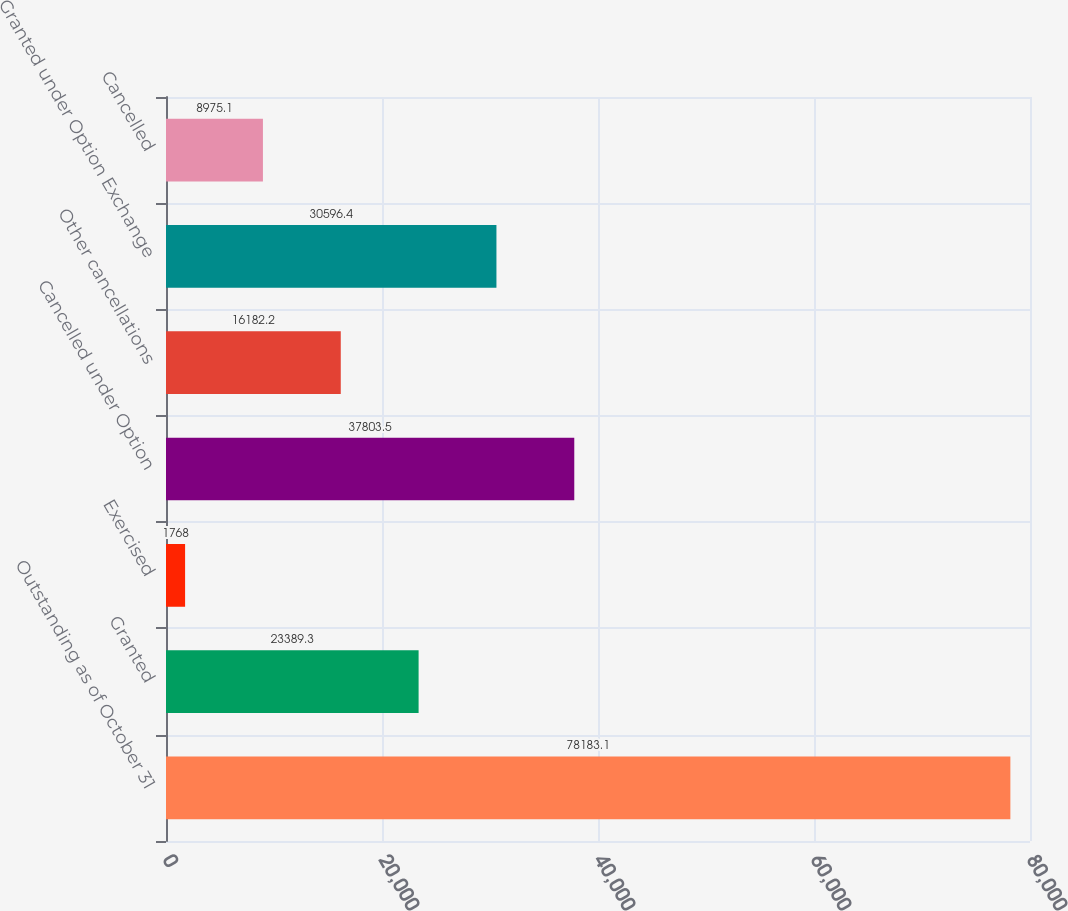<chart> <loc_0><loc_0><loc_500><loc_500><bar_chart><fcel>Outstanding as of October 31<fcel>Granted<fcel>Exercised<fcel>Cancelled under Option<fcel>Other cancellations<fcel>Granted under Option Exchange<fcel>Cancelled<nl><fcel>78183.1<fcel>23389.3<fcel>1768<fcel>37803.5<fcel>16182.2<fcel>30596.4<fcel>8975.1<nl></chart> 